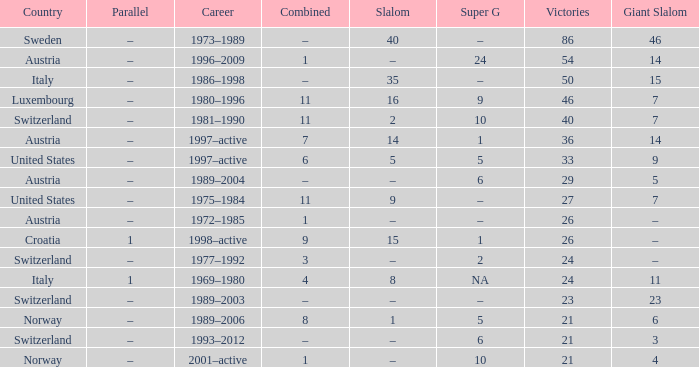What Career has a Super G of 5, and a Combined of 6? 1997–active. 